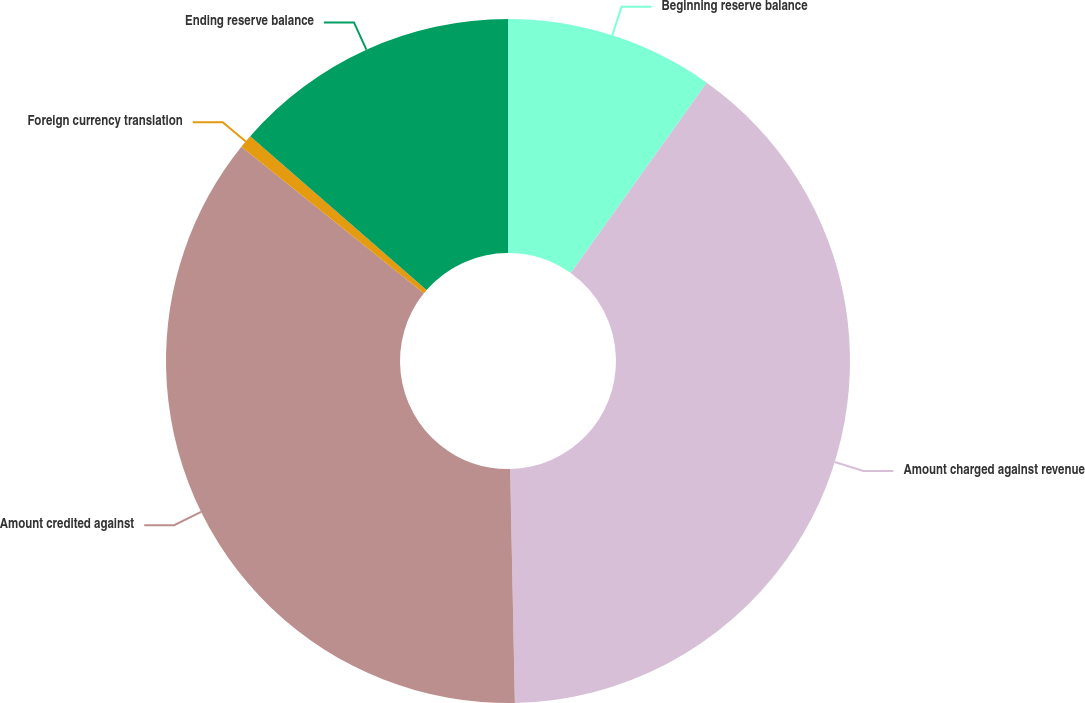Convert chart to OTSL. <chart><loc_0><loc_0><loc_500><loc_500><pie_chart><fcel>Beginning reserve balance<fcel>Amount charged against revenue<fcel>Amount credited against<fcel>Foreign currency translation<fcel>Ending reserve balance<nl><fcel>9.87%<fcel>39.81%<fcel>36.09%<fcel>0.64%<fcel>13.59%<nl></chart> 